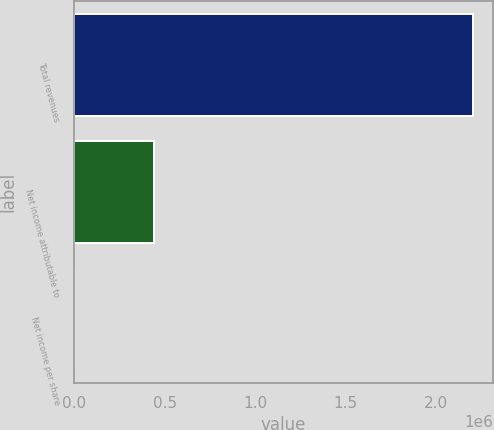<chart> <loc_0><loc_0><loc_500><loc_500><bar_chart><fcel>Total revenues<fcel>Net income attributable to<fcel>Net income per share<nl><fcel>2.20385e+06<fcel>440771<fcel>2.37<nl></chart> 